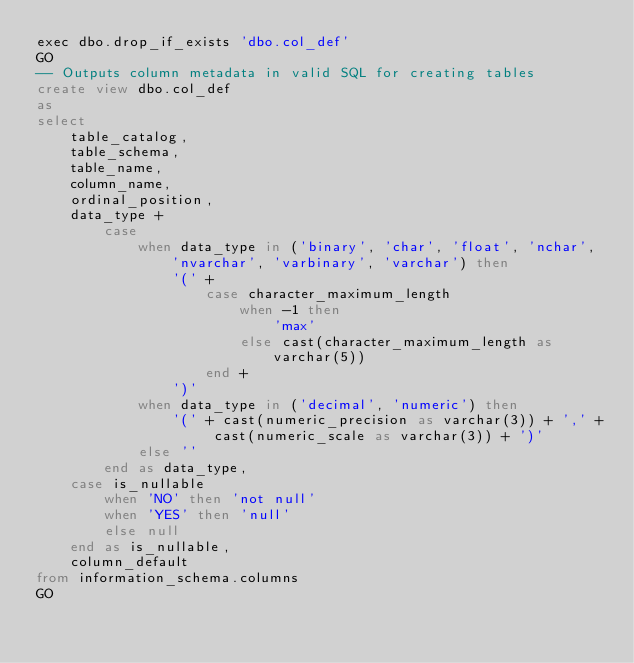<code> <loc_0><loc_0><loc_500><loc_500><_SQL_>exec dbo.drop_if_exists 'dbo.col_def'
GO
-- Outputs column metadata in valid SQL for creating tables
create view dbo.col_def
as
select
	table_catalog,
	table_schema,
	table_name,
	column_name,
	ordinal_position,
	data_type +
		case
			when data_type in ('binary', 'char', 'float', 'nchar', 'nvarchar', 'varbinary', 'varchar') then
				'(' +
					case character_maximum_length
						when -1 then
							'max'
						else cast(character_maximum_length as varchar(5))
					end +
				')'
			when data_type in ('decimal', 'numeric') then
				'(' + cast(numeric_precision as varchar(3)) + ',' + cast(numeric_scale as varchar(3)) + ')'
			else ''
		end as data_type,
	case is_nullable
		when 'NO' then 'not null'
		when 'YES' then 'null'
		else null
	end as is_nullable,
	column_default
from information_schema.columns
GO</code> 